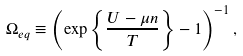<formula> <loc_0><loc_0><loc_500><loc_500>\Omega _ { e q } \equiv \left ( \exp \left \{ \frac { U - \mu n } { T } \right \} - 1 \right ) ^ { - 1 } ,</formula> 